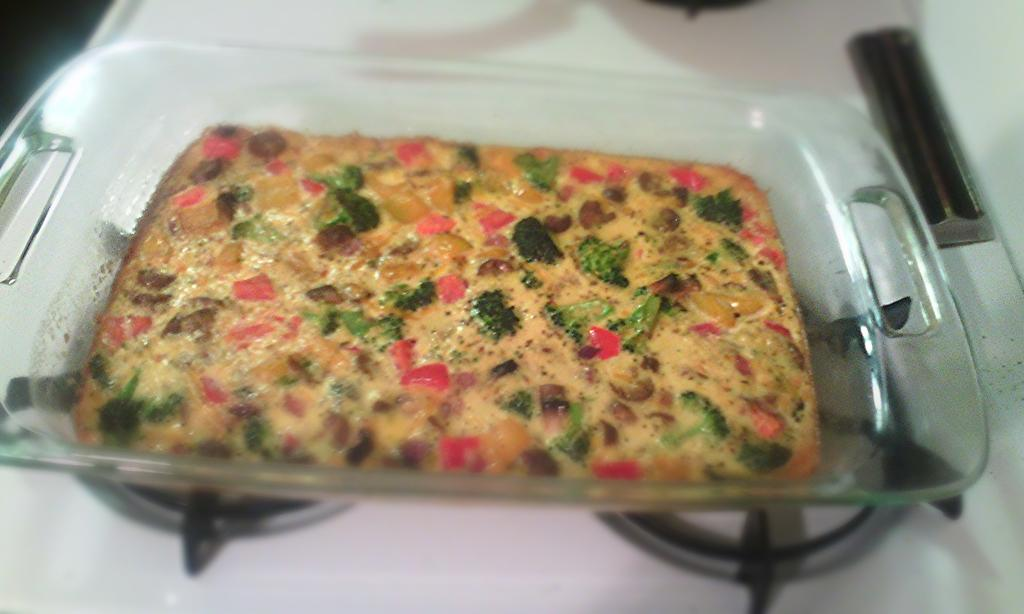What is located in the center of the image? There is a tray in the center of the image. What is on the tray? There is food on the tray. What can be seen at the bottom of the image? There is a stove at the bottom of the image. What type of weather is depicted in the image? There is no weather depicted in the image; it is an indoor scene with a tray, food, and a stove. 